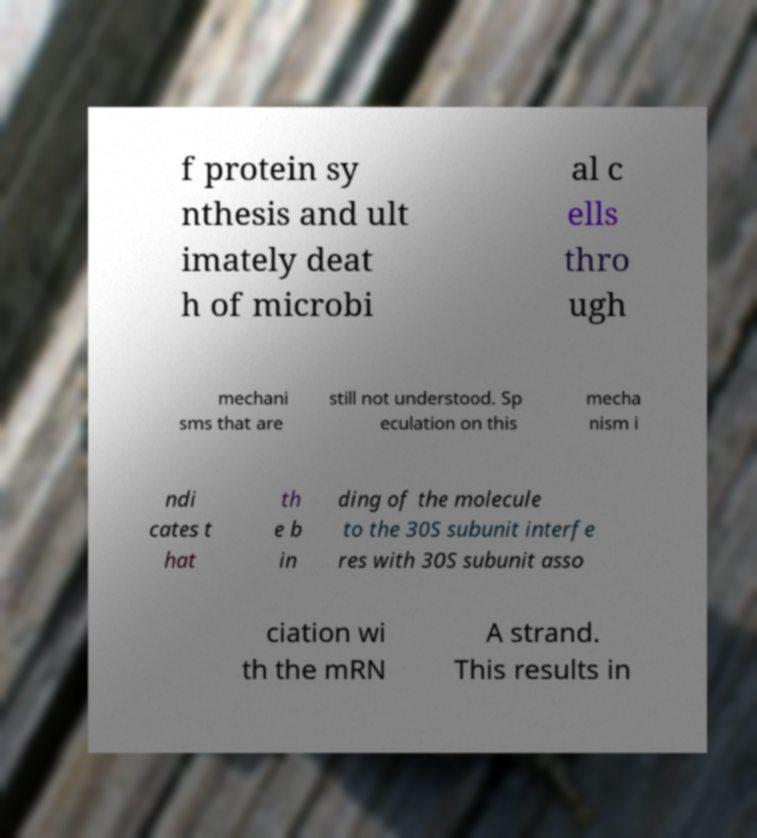Please identify and transcribe the text found in this image. f protein sy nthesis and ult imately deat h of microbi al c ells thro ugh mechani sms that are still not understood. Sp eculation on this mecha nism i ndi cates t hat th e b in ding of the molecule to the 30S subunit interfe res with 30S subunit asso ciation wi th the mRN A strand. This results in 